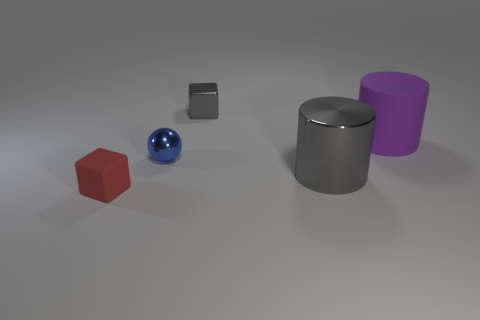Does the tiny blue sphere have the same material as the purple thing?
Offer a terse response. No. The rubber thing that is on the right side of the tiny cube that is in front of the large thing that is to the right of the large metal cylinder is what shape?
Ensure brevity in your answer.  Cylinder. Is the number of gray cylinders that are to the left of the small gray thing less than the number of blue shiny spheres right of the large gray object?
Ensure brevity in your answer.  No. There is a matte thing in front of the metallic thing that is to the left of the gray block; what is its shape?
Your response must be concise. Cube. Is there anything else of the same color as the small ball?
Offer a very short reply. No. Is the tiny rubber thing the same color as the big matte thing?
Provide a short and direct response. No. What number of yellow objects are either metallic cylinders or rubber objects?
Offer a terse response. 0. Are there fewer tiny spheres behind the small gray object than large gray cylinders?
Offer a very short reply. Yes. How many rubber objects are behind the gray shiny object that is behind the tiny metallic ball?
Offer a terse response. 0. What number of other objects are the same size as the blue object?
Provide a short and direct response. 2. 